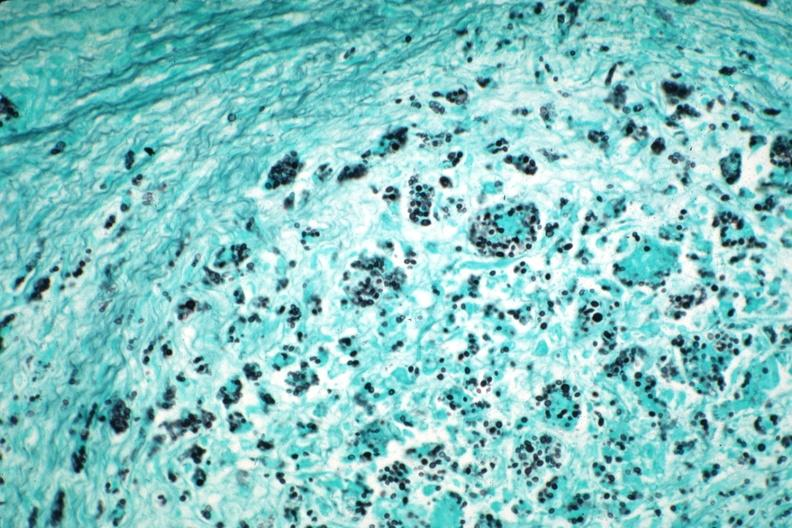does gms illustrate organisms granulomatous prostatitis case of aids?
Answer the question using a single word or phrase. Yes 